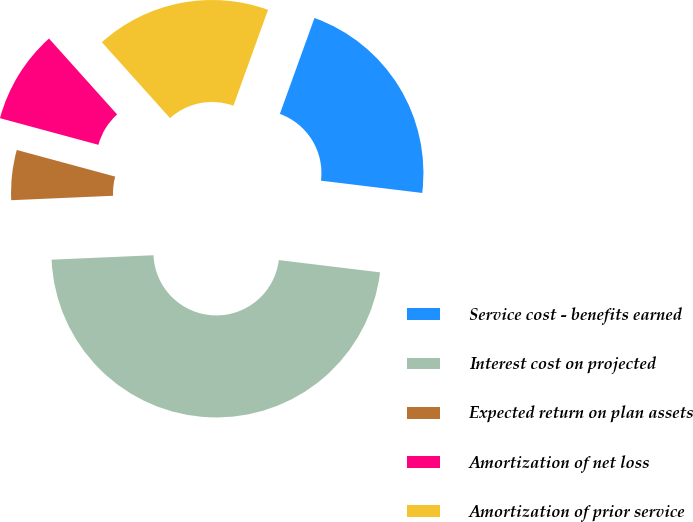Convert chart. <chart><loc_0><loc_0><loc_500><loc_500><pie_chart><fcel>Service cost - benefits earned<fcel>Interest cost on projected<fcel>Expected return on plan assets<fcel>Amortization of net loss<fcel>Amortization of prior service<nl><fcel>21.41%<fcel>47.39%<fcel>4.9%<fcel>9.15%<fcel>17.16%<nl></chart> 